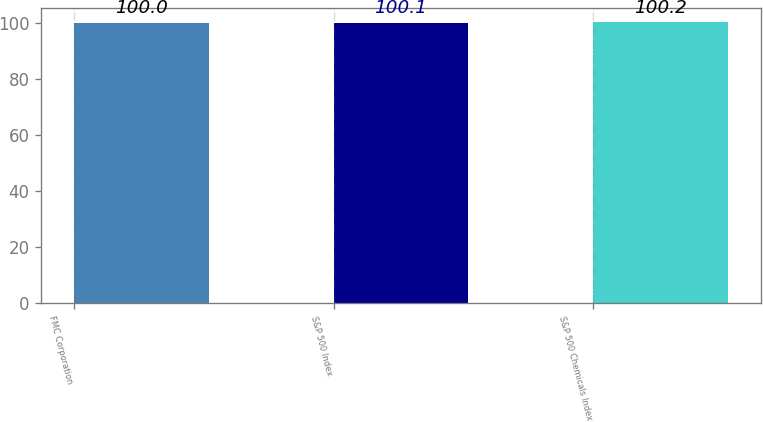Convert chart. <chart><loc_0><loc_0><loc_500><loc_500><bar_chart><fcel>FMC Corporation<fcel>S&P 500 Index<fcel>S&P 500 Chemicals Index<nl><fcel>100<fcel>100.1<fcel>100.2<nl></chart> 